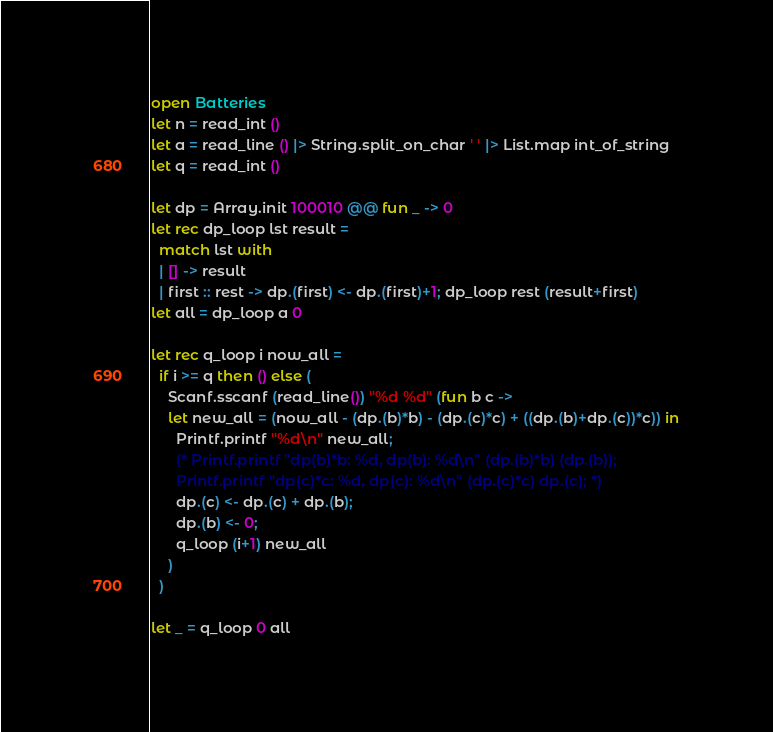<code> <loc_0><loc_0><loc_500><loc_500><_OCaml_>open Batteries
let n = read_int ()
let a = read_line () |> String.split_on_char ' ' |> List.map int_of_string
let q = read_int ()

let dp = Array.init 100010 @@ fun _ -> 0
let rec dp_loop lst result =
  match lst with
  | [] -> result
  | first :: rest -> dp.(first) <- dp.(first)+1; dp_loop rest (result+first)
let all = dp_loop a 0

let rec q_loop i now_all =
  if i >= q then () else (
    Scanf.sscanf (read_line()) "%d %d" (fun b c -> 
    let new_all = (now_all - (dp.(b)*b) - (dp.(c)*c) + ((dp.(b)+dp.(c))*c)) in
      Printf.printf "%d\n" new_all;
      (* Printf.printf "dp(b)*b: %d, dp(b): %d\n" (dp.(b)*b) (dp.(b));
      Printf.printf "dp(c)*c: %d, dp(c): %d\n" (dp.(c)*c) dp.(c); *)
      dp.(c) <- dp.(c) + dp.(b);
      dp.(b) <- 0;
      q_loop (i+1) new_all
    )
  )

let _ = q_loop 0 all</code> 